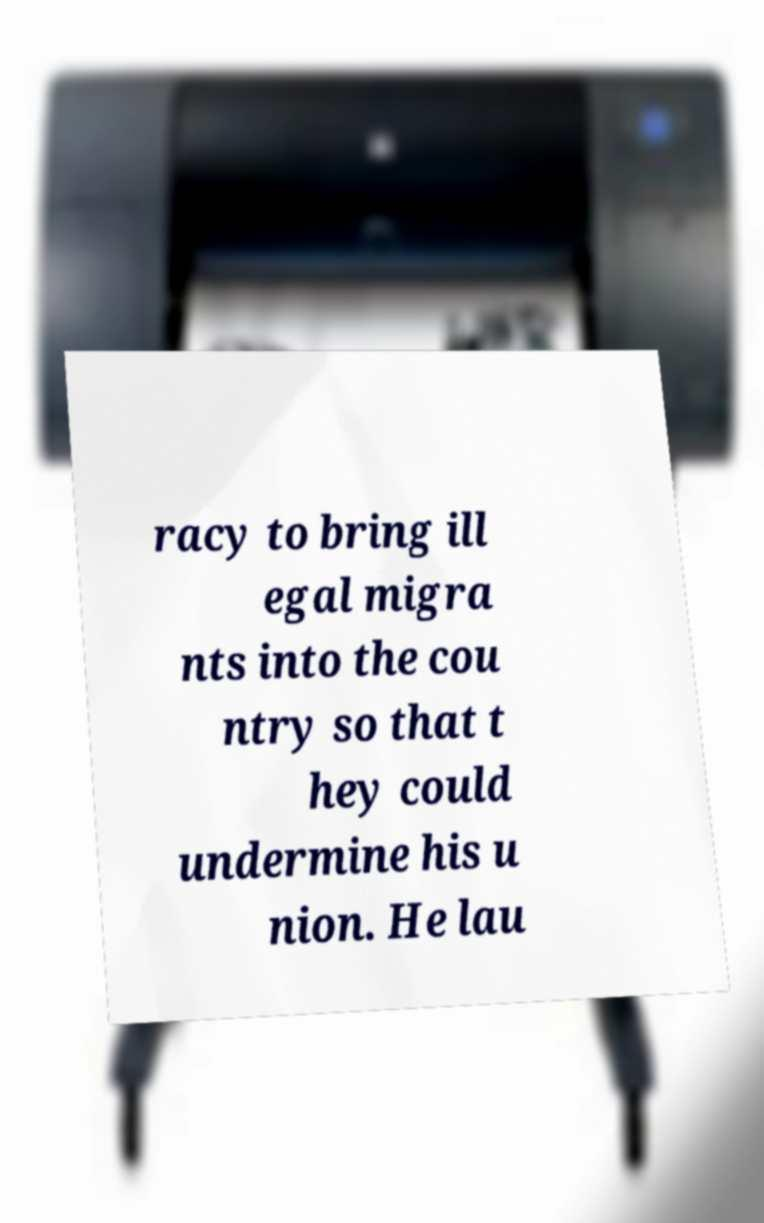Can you read and provide the text displayed in the image?This photo seems to have some interesting text. Can you extract and type it out for me? racy to bring ill egal migra nts into the cou ntry so that t hey could undermine his u nion. He lau 